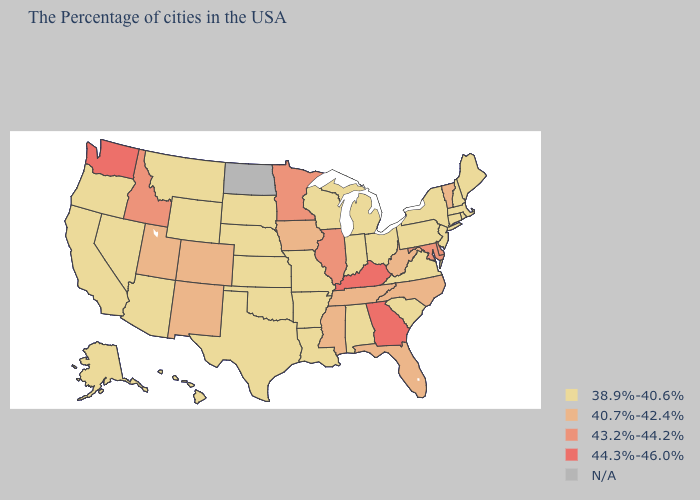Which states have the highest value in the USA?
Answer briefly. Georgia, Kentucky, Washington. Does Illinois have the highest value in the MidWest?
Concise answer only. Yes. Among the states that border Washington , which have the lowest value?
Write a very short answer. Oregon. Name the states that have a value in the range 38.9%-40.6%?
Keep it brief. Maine, Massachusetts, Rhode Island, New Hampshire, Connecticut, New York, New Jersey, Pennsylvania, Virginia, South Carolina, Ohio, Michigan, Indiana, Alabama, Wisconsin, Louisiana, Missouri, Arkansas, Kansas, Nebraska, Oklahoma, Texas, South Dakota, Wyoming, Montana, Arizona, Nevada, California, Oregon, Alaska, Hawaii. What is the value of Illinois?
Short answer required. 43.2%-44.2%. Among the states that border Missouri , which have the highest value?
Write a very short answer. Kentucky. What is the value of Montana?
Answer briefly. 38.9%-40.6%. Does Delaware have the lowest value in the USA?
Short answer required. No. What is the value of Mississippi?
Answer briefly. 40.7%-42.4%. What is the value of New Hampshire?
Be succinct. 38.9%-40.6%. Does the first symbol in the legend represent the smallest category?
Concise answer only. Yes. What is the lowest value in states that border South Dakota?
Keep it brief. 38.9%-40.6%. Which states have the highest value in the USA?
Quick response, please. Georgia, Kentucky, Washington. Name the states that have a value in the range 44.3%-46.0%?
Give a very brief answer. Georgia, Kentucky, Washington. 